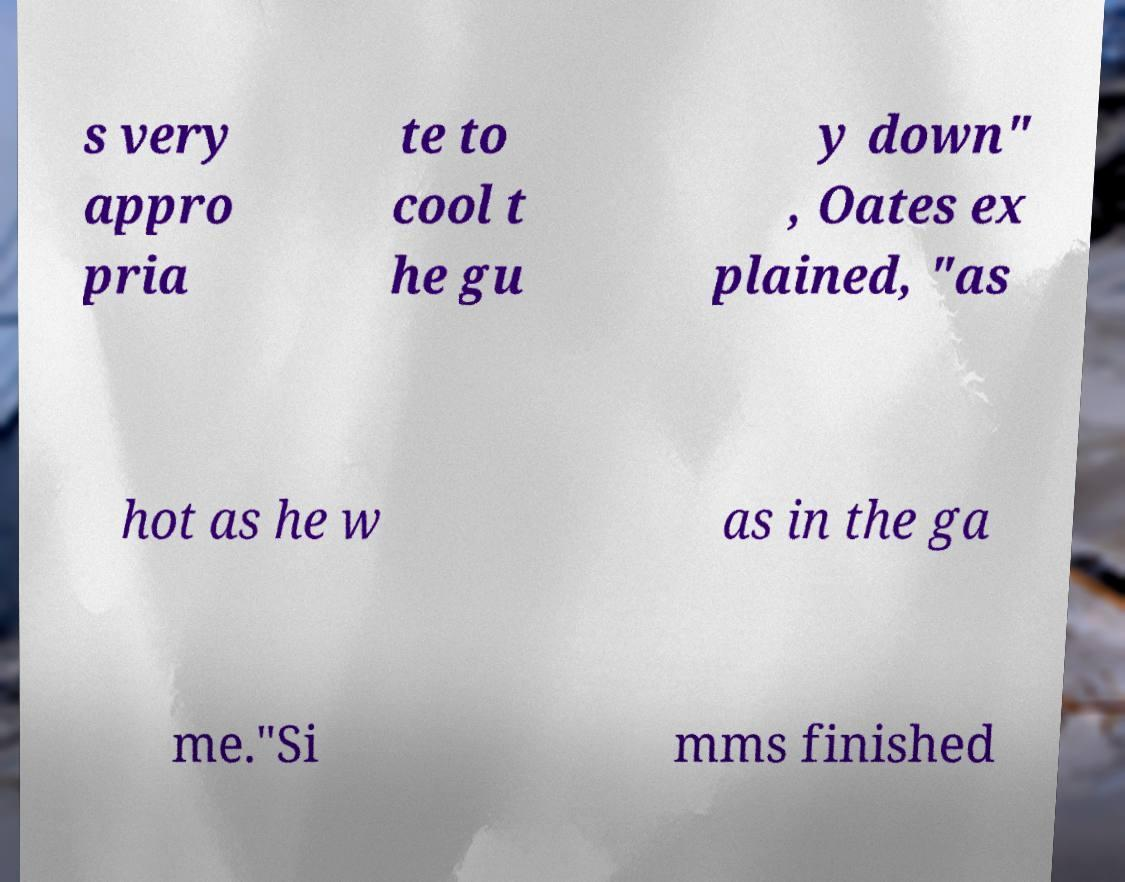Could you assist in decoding the text presented in this image and type it out clearly? s very appro pria te to cool t he gu y down" , Oates ex plained, "as hot as he w as in the ga me."Si mms finished 